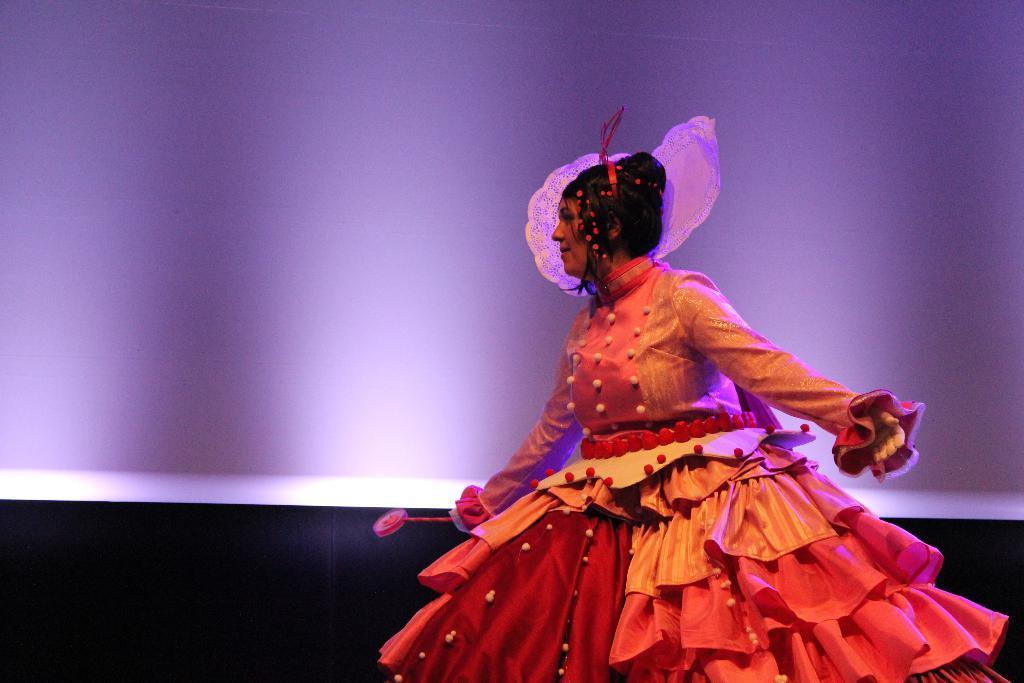Could you give a brief overview of what you see in this image? In the foreground I can see a woman on the stage. In the background I can see a wall of purple in color. This image is taken on the stage. 